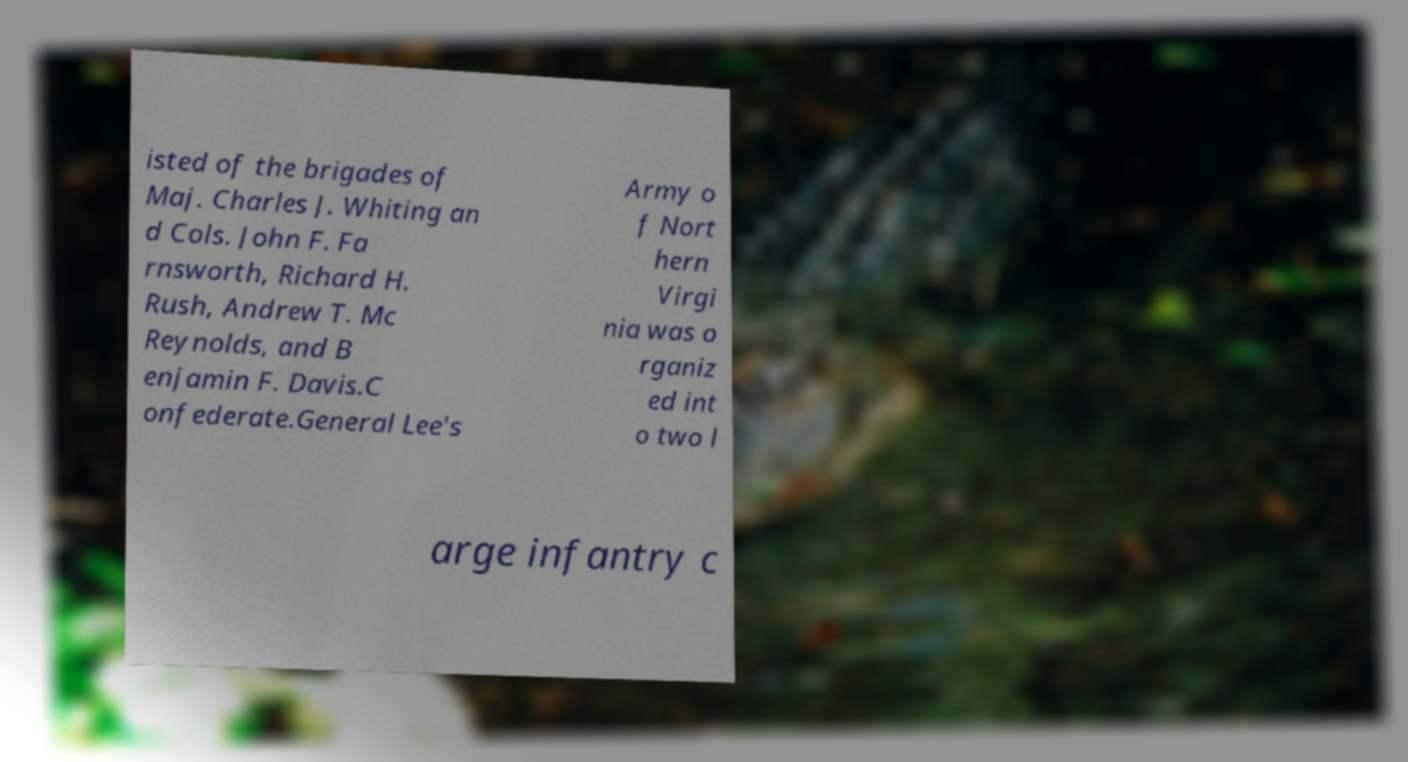There's text embedded in this image that I need extracted. Can you transcribe it verbatim? isted of the brigades of Maj. Charles J. Whiting an d Cols. John F. Fa rnsworth, Richard H. Rush, Andrew T. Mc Reynolds, and B enjamin F. Davis.C onfederate.General Lee's Army o f Nort hern Virgi nia was o rganiz ed int o two l arge infantry c 